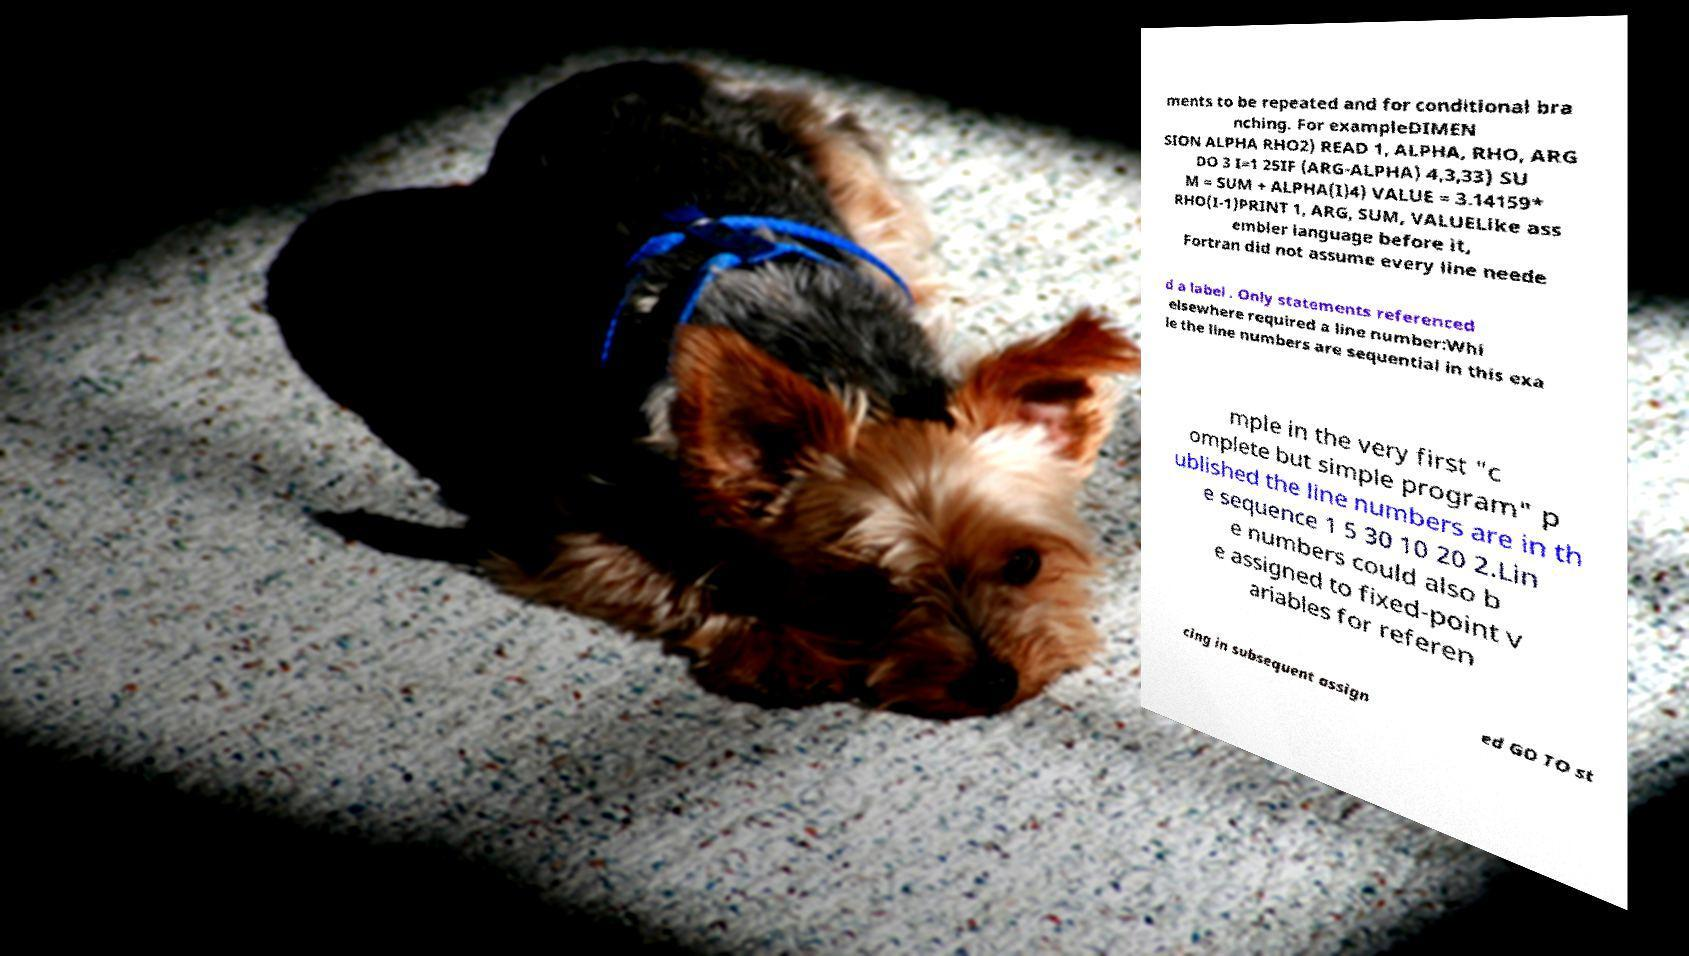Please identify and transcribe the text found in this image. ments to be repeated and for conditional bra nching. For exampleDIMEN SION ALPHA RHO2) READ 1, ALPHA, RHO, ARG DO 3 I=1 25IF (ARG-ALPHA) 4,3,33) SU M = SUM + ALPHA(I)4) VALUE = 3.14159* RHO(I-1)PRINT 1, ARG, SUM, VALUELike ass embler language before it, Fortran did not assume every line neede d a label . Only statements referenced elsewhere required a line number:Whi le the line numbers are sequential in this exa mple in the very first "c omplete but simple program" p ublished the line numbers are in th e sequence 1 5 30 10 20 2.Lin e numbers could also b e assigned to fixed-point v ariables for referen cing in subsequent assign ed GO TO st 